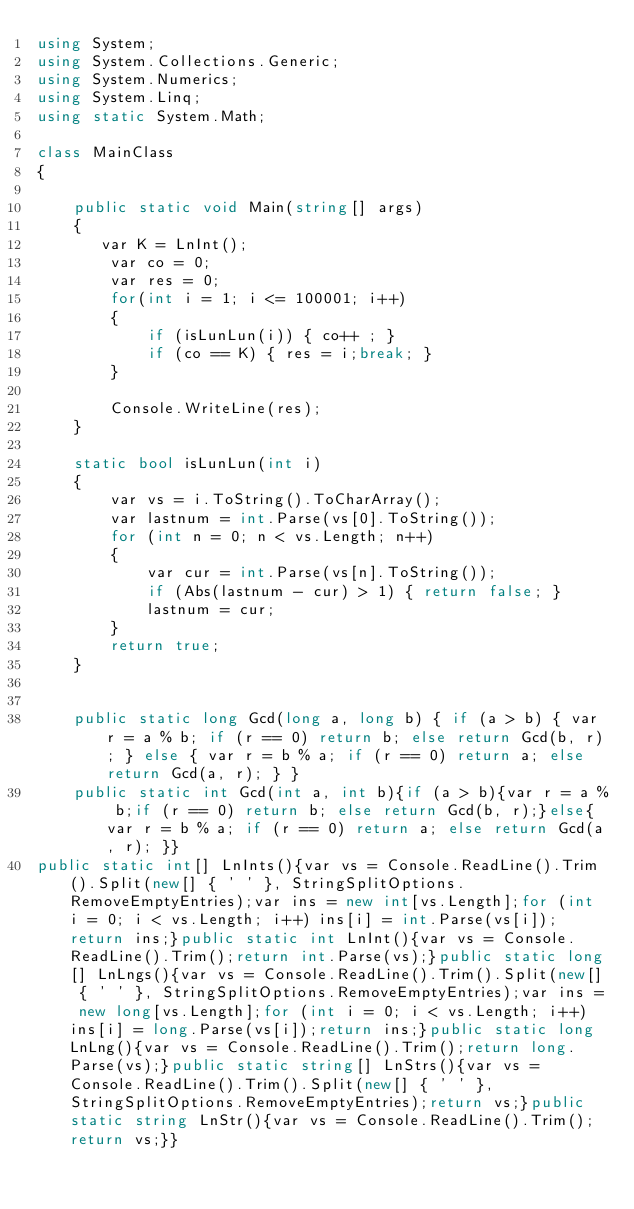<code> <loc_0><loc_0><loc_500><loc_500><_C#_>using System;
using System.Collections.Generic;
using System.Numerics;
using System.Linq;
using static System.Math;

class MainClass
{

    public static void Main(string[] args)
    {
       var K = LnInt();
        var co = 0;
        var res = 0;
        for(int i = 1; i <= 100001; i++)
        {
            if (isLunLun(i)) { co++ ; }
            if (co == K) { res = i;break; }
        }

        Console.WriteLine(res);
    }

    static bool isLunLun(int i)
    {
        var vs = i.ToString().ToCharArray();
        var lastnum = int.Parse(vs[0].ToString());
        for (int n = 0; n < vs.Length; n++)
        {
            var cur = int.Parse(vs[n].ToString());
            if (Abs(lastnum - cur) > 1) { return false; }
            lastnum = cur;
        }
        return true;
    }


    public static long Gcd(long a, long b) { if (a > b) { var r = a % b; if (r == 0) return b; else return Gcd(b, r); } else { var r = b % a; if (r == 0) return a; else return Gcd(a, r); } }
    public static int Gcd(int a, int b){if (a > b){var r = a % b;if (r == 0) return b; else return Gcd(b, r);}else{ var r = b % a; if (r == 0) return a; else return Gcd(a, r); }}
public static int[] LnInts(){var vs = Console.ReadLine().Trim().Split(new[] { ' ' }, StringSplitOptions.RemoveEmptyEntries);var ins = new int[vs.Length];for (int i = 0; i < vs.Length; i++) ins[i] = int.Parse(vs[i]);return ins;}public static int LnInt(){var vs = Console.ReadLine().Trim();return int.Parse(vs);}public static long[] LnLngs(){var vs = Console.ReadLine().Trim().Split(new[] { ' ' }, StringSplitOptions.RemoveEmptyEntries);var ins = new long[vs.Length];for (int i = 0; i < vs.Length; i++) ins[i] = long.Parse(vs[i]);return ins;}public static long LnLng(){var vs = Console.ReadLine().Trim();return long.Parse(vs);}public static string[] LnStrs(){var vs = Console.ReadLine().Trim().Split(new[] { ' ' }, StringSplitOptions.RemoveEmptyEntries);return vs;}public static string LnStr(){var vs = Console.ReadLine().Trim();return vs;}}

</code> 